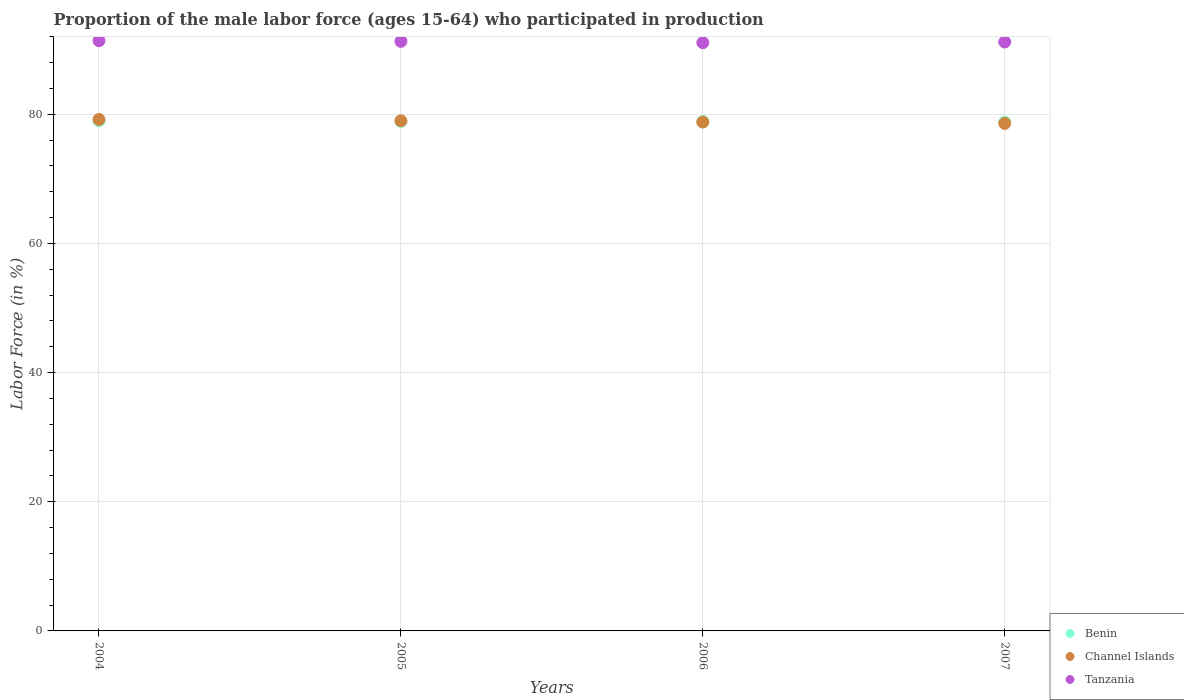How many different coloured dotlines are there?
Give a very brief answer. 3. What is the proportion of the male labor force who participated in production in Tanzania in 2006?
Make the answer very short. 91.1. Across all years, what is the maximum proportion of the male labor force who participated in production in Channel Islands?
Offer a terse response. 79.2. Across all years, what is the minimum proportion of the male labor force who participated in production in Benin?
Provide a short and direct response. 78.8. In which year was the proportion of the male labor force who participated in production in Channel Islands maximum?
Give a very brief answer. 2004. What is the total proportion of the male labor force who participated in production in Tanzania in the graph?
Your answer should be compact. 365. What is the difference between the proportion of the male labor force who participated in production in Channel Islands in 2004 and that in 2006?
Provide a succinct answer. 0.4. What is the difference between the proportion of the male labor force who participated in production in Benin in 2005 and the proportion of the male labor force who participated in production in Channel Islands in 2007?
Offer a very short reply. 0.3. What is the average proportion of the male labor force who participated in production in Channel Islands per year?
Offer a terse response. 78.9. In the year 2006, what is the difference between the proportion of the male labor force who participated in production in Tanzania and proportion of the male labor force who participated in production in Channel Islands?
Give a very brief answer. 12.3. In how many years, is the proportion of the male labor force who participated in production in Benin greater than 48 %?
Offer a very short reply. 4. What is the ratio of the proportion of the male labor force who participated in production in Benin in 2005 to that in 2007?
Provide a short and direct response. 1. Is the proportion of the male labor force who participated in production in Tanzania in 2004 less than that in 2007?
Provide a succinct answer. No. What is the difference between the highest and the second highest proportion of the male labor force who participated in production in Channel Islands?
Your response must be concise. 0.2. What is the difference between the highest and the lowest proportion of the male labor force who participated in production in Benin?
Your answer should be compact. 0.2. Is it the case that in every year, the sum of the proportion of the male labor force who participated in production in Tanzania and proportion of the male labor force who participated in production in Channel Islands  is greater than the proportion of the male labor force who participated in production in Benin?
Offer a very short reply. Yes. Is the proportion of the male labor force who participated in production in Tanzania strictly less than the proportion of the male labor force who participated in production in Channel Islands over the years?
Keep it short and to the point. No. What is the difference between two consecutive major ticks on the Y-axis?
Provide a succinct answer. 20. Does the graph contain any zero values?
Your response must be concise. No. Does the graph contain grids?
Offer a terse response. Yes. Where does the legend appear in the graph?
Make the answer very short. Bottom right. How many legend labels are there?
Provide a succinct answer. 3. How are the legend labels stacked?
Make the answer very short. Vertical. What is the title of the graph?
Make the answer very short. Proportion of the male labor force (ages 15-64) who participated in production. Does "Guam" appear as one of the legend labels in the graph?
Your answer should be very brief. No. What is the Labor Force (in %) of Benin in 2004?
Your response must be concise. 79. What is the Labor Force (in %) in Channel Islands in 2004?
Keep it short and to the point. 79.2. What is the Labor Force (in %) of Tanzania in 2004?
Give a very brief answer. 91.4. What is the Labor Force (in %) in Benin in 2005?
Keep it short and to the point. 78.9. What is the Labor Force (in %) of Channel Islands in 2005?
Make the answer very short. 79. What is the Labor Force (in %) in Tanzania in 2005?
Offer a very short reply. 91.3. What is the Labor Force (in %) in Benin in 2006?
Keep it short and to the point. 78.9. What is the Labor Force (in %) in Channel Islands in 2006?
Provide a short and direct response. 78.8. What is the Labor Force (in %) in Tanzania in 2006?
Offer a very short reply. 91.1. What is the Labor Force (in %) of Benin in 2007?
Your answer should be very brief. 78.8. What is the Labor Force (in %) of Channel Islands in 2007?
Keep it short and to the point. 78.6. What is the Labor Force (in %) in Tanzania in 2007?
Your response must be concise. 91.2. Across all years, what is the maximum Labor Force (in %) of Benin?
Make the answer very short. 79. Across all years, what is the maximum Labor Force (in %) in Channel Islands?
Provide a succinct answer. 79.2. Across all years, what is the maximum Labor Force (in %) of Tanzania?
Provide a short and direct response. 91.4. Across all years, what is the minimum Labor Force (in %) in Benin?
Offer a very short reply. 78.8. Across all years, what is the minimum Labor Force (in %) of Channel Islands?
Offer a terse response. 78.6. Across all years, what is the minimum Labor Force (in %) of Tanzania?
Provide a short and direct response. 91.1. What is the total Labor Force (in %) in Benin in the graph?
Provide a short and direct response. 315.6. What is the total Labor Force (in %) in Channel Islands in the graph?
Your answer should be compact. 315.6. What is the total Labor Force (in %) in Tanzania in the graph?
Make the answer very short. 365. What is the difference between the Labor Force (in %) in Benin in 2004 and that in 2006?
Keep it short and to the point. 0.1. What is the difference between the Labor Force (in %) in Channel Islands in 2004 and that in 2006?
Provide a short and direct response. 0.4. What is the difference between the Labor Force (in %) of Tanzania in 2004 and that in 2006?
Offer a terse response. 0.3. What is the difference between the Labor Force (in %) of Benin in 2004 and that in 2007?
Offer a terse response. 0.2. What is the difference between the Labor Force (in %) in Channel Islands in 2005 and that in 2006?
Make the answer very short. 0.2. What is the difference between the Labor Force (in %) in Tanzania in 2005 and that in 2006?
Offer a very short reply. 0.2. What is the difference between the Labor Force (in %) of Tanzania in 2005 and that in 2007?
Offer a very short reply. 0.1. What is the difference between the Labor Force (in %) of Benin in 2006 and that in 2007?
Offer a very short reply. 0.1. What is the difference between the Labor Force (in %) of Benin in 2004 and the Labor Force (in %) of Channel Islands in 2005?
Ensure brevity in your answer.  0. What is the difference between the Labor Force (in %) in Channel Islands in 2004 and the Labor Force (in %) in Tanzania in 2005?
Make the answer very short. -12.1. What is the difference between the Labor Force (in %) of Benin in 2004 and the Labor Force (in %) of Channel Islands in 2006?
Provide a succinct answer. 0.2. What is the difference between the Labor Force (in %) of Benin in 2004 and the Labor Force (in %) of Tanzania in 2006?
Offer a terse response. -12.1. What is the difference between the Labor Force (in %) of Benin in 2004 and the Labor Force (in %) of Tanzania in 2007?
Provide a succinct answer. -12.2. What is the difference between the Labor Force (in %) in Benin in 2005 and the Labor Force (in %) in Channel Islands in 2006?
Give a very brief answer. 0.1. What is the difference between the Labor Force (in %) of Channel Islands in 2005 and the Labor Force (in %) of Tanzania in 2007?
Your response must be concise. -12.2. What is the average Labor Force (in %) of Benin per year?
Offer a very short reply. 78.9. What is the average Labor Force (in %) of Channel Islands per year?
Your answer should be very brief. 78.9. What is the average Labor Force (in %) in Tanzania per year?
Your response must be concise. 91.25. In the year 2004, what is the difference between the Labor Force (in %) in Benin and Labor Force (in %) in Channel Islands?
Ensure brevity in your answer.  -0.2. In the year 2004, what is the difference between the Labor Force (in %) in Benin and Labor Force (in %) in Tanzania?
Provide a short and direct response. -12.4. In the year 2006, what is the difference between the Labor Force (in %) in Channel Islands and Labor Force (in %) in Tanzania?
Offer a very short reply. -12.3. In the year 2007, what is the difference between the Labor Force (in %) in Benin and Labor Force (in %) in Channel Islands?
Offer a very short reply. 0.2. In the year 2007, what is the difference between the Labor Force (in %) of Benin and Labor Force (in %) of Tanzania?
Your answer should be very brief. -12.4. What is the ratio of the Labor Force (in %) of Benin in 2004 to that in 2005?
Your response must be concise. 1. What is the ratio of the Labor Force (in %) in Channel Islands in 2004 to that in 2005?
Provide a succinct answer. 1. What is the ratio of the Labor Force (in %) in Channel Islands in 2004 to that in 2006?
Ensure brevity in your answer.  1.01. What is the ratio of the Labor Force (in %) of Tanzania in 2004 to that in 2006?
Provide a succinct answer. 1. What is the ratio of the Labor Force (in %) in Benin in 2004 to that in 2007?
Your answer should be compact. 1. What is the ratio of the Labor Force (in %) of Channel Islands in 2004 to that in 2007?
Offer a very short reply. 1.01. What is the ratio of the Labor Force (in %) of Tanzania in 2004 to that in 2007?
Your answer should be compact. 1. What is the ratio of the Labor Force (in %) in Benin in 2005 to that in 2006?
Your response must be concise. 1. What is the ratio of the Labor Force (in %) in Channel Islands in 2005 to that in 2006?
Provide a succinct answer. 1. What is the ratio of the Labor Force (in %) of Tanzania in 2006 to that in 2007?
Provide a short and direct response. 1. What is the difference between the highest and the second highest Labor Force (in %) of Tanzania?
Make the answer very short. 0.1. What is the difference between the highest and the lowest Labor Force (in %) of Benin?
Give a very brief answer. 0.2. What is the difference between the highest and the lowest Labor Force (in %) of Tanzania?
Keep it short and to the point. 0.3. 